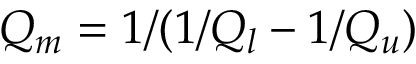<formula> <loc_0><loc_0><loc_500><loc_500>Q _ { m } = 1 / ( 1 / Q _ { l } - 1 / Q _ { u } )</formula> 